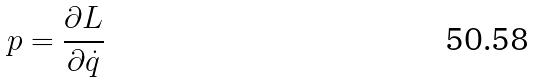<formula> <loc_0><loc_0><loc_500><loc_500>p = \frac { \partial L } { \partial \dot { q } }</formula> 